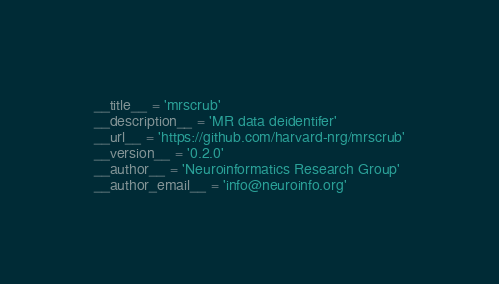Convert code to text. <code><loc_0><loc_0><loc_500><loc_500><_Python_>__title__ = 'mrscrub'
__description__ = 'MR data deidentifer'
__url__ = 'https://github.com/harvard-nrg/mrscrub'
__version__ = '0.2.0'
__author__ = 'Neuroinformatics Research Group'
__author_email__ = 'info@neuroinfo.org'
</code> 